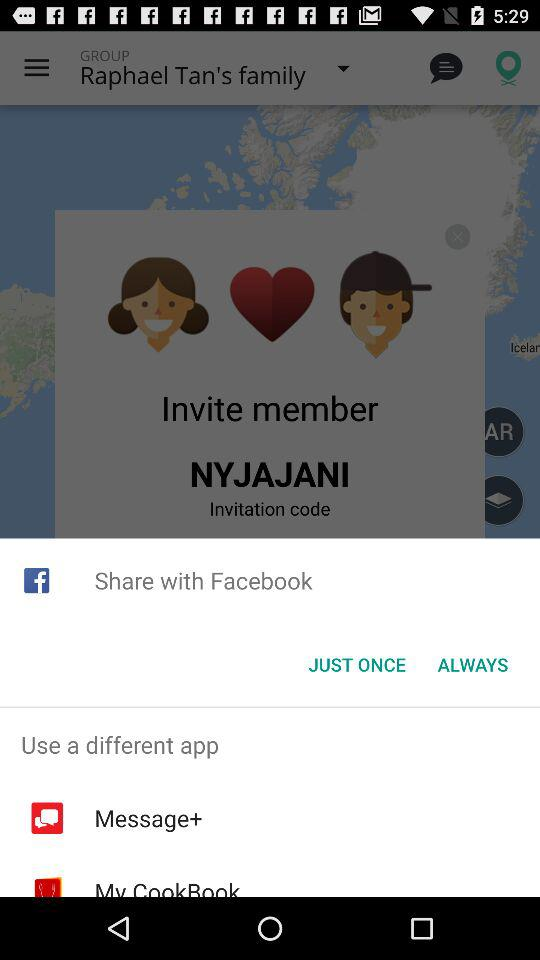Whose family group is shown? The one whose family group is shown is Raphael Tan. 